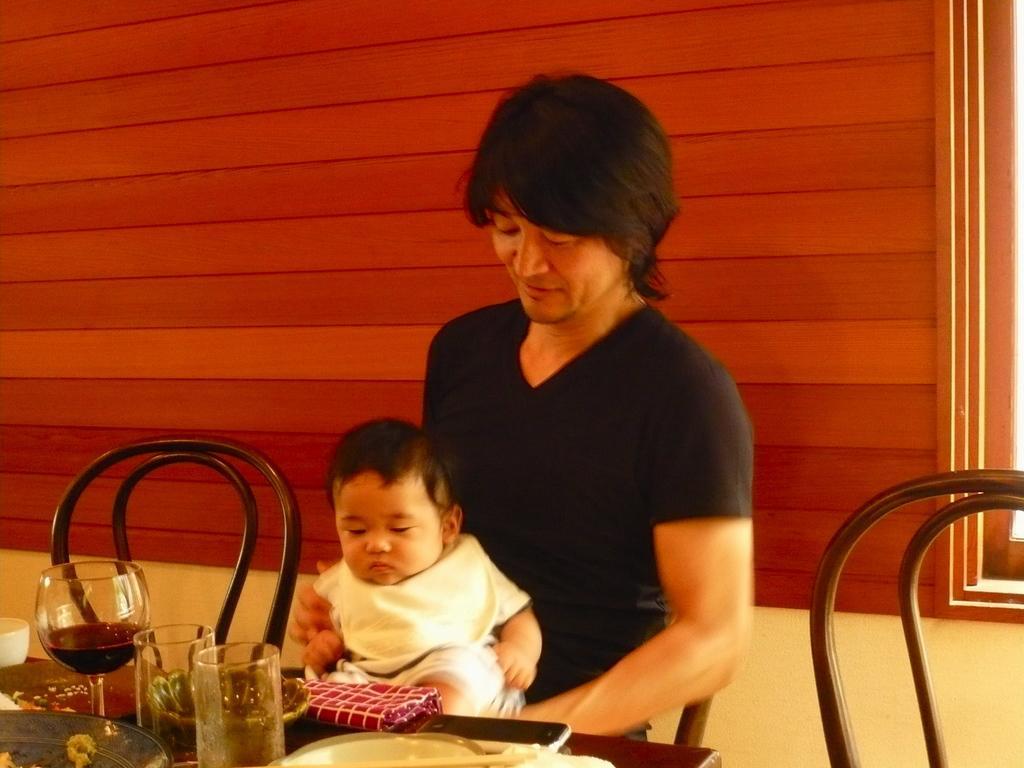How would you summarize this image in a sentence or two? In this image I see a man who is holding a baby and he is sitting on a chair, I can also see there are two chairs over here and I see a table in front of him on which there are glasses, cloth, plates, and a phone. In the background I see the wall. 